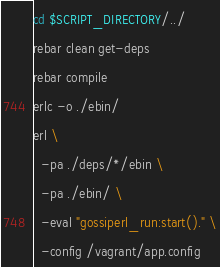<code> <loc_0><loc_0><loc_500><loc_500><_Bash_>cd $SCRIPT_DIRECTORY/../
rebar clean get-deps
rebar compile
erlc -o ./ebin/
erl \
  -pa ./deps/*/ebin \
  -pa ./ebin/ \
  -eval "gossiperl_run:start()." \
  -config /vagrant/app.config</code> 